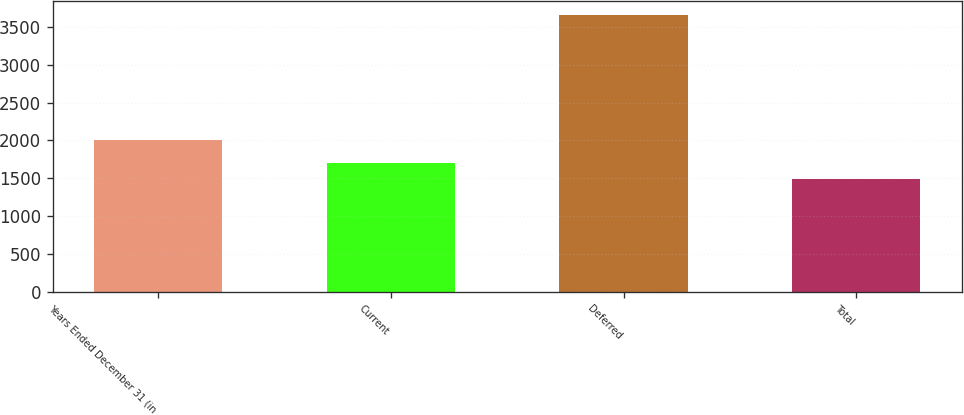Convert chart. <chart><loc_0><loc_0><loc_500><loc_500><bar_chart><fcel>Years Ended December 31 (in<fcel>Current<fcel>Deferred<fcel>Total<nl><fcel>2009<fcel>1706.2<fcel>3661<fcel>1489<nl></chart> 